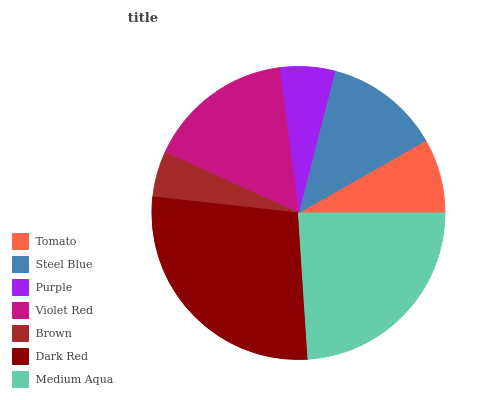Is Brown the minimum?
Answer yes or no. Yes. Is Dark Red the maximum?
Answer yes or no. Yes. Is Steel Blue the minimum?
Answer yes or no. No. Is Steel Blue the maximum?
Answer yes or no. No. Is Steel Blue greater than Tomato?
Answer yes or no. Yes. Is Tomato less than Steel Blue?
Answer yes or no. Yes. Is Tomato greater than Steel Blue?
Answer yes or no. No. Is Steel Blue less than Tomato?
Answer yes or no. No. Is Steel Blue the high median?
Answer yes or no. Yes. Is Steel Blue the low median?
Answer yes or no. Yes. Is Tomato the high median?
Answer yes or no. No. Is Dark Red the low median?
Answer yes or no. No. 